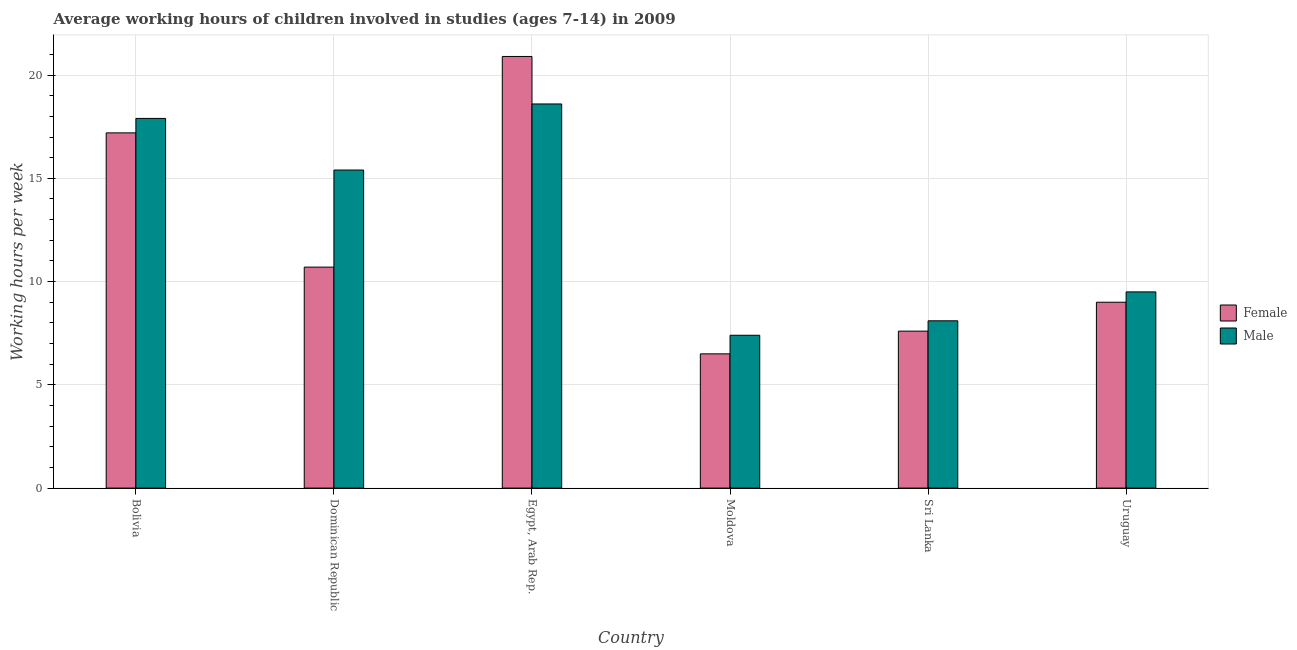Are the number of bars per tick equal to the number of legend labels?
Your response must be concise. Yes. How many bars are there on the 3rd tick from the left?
Make the answer very short. 2. How many bars are there on the 2nd tick from the right?
Provide a short and direct response. 2. What is the label of the 6th group of bars from the left?
Offer a terse response. Uruguay. Across all countries, what is the maximum average working hour of male children?
Your answer should be very brief. 18.6. Across all countries, what is the minimum average working hour of male children?
Your answer should be compact. 7.4. In which country was the average working hour of female children maximum?
Your response must be concise. Egypt, Arab Rep. In which country was the average working hour of male children minimum?
Give a very brief answer. Moldova. What is the total average working hour of male children in the graph?
Your response must be concise. 76.9. What is the difference between the average working hour of female children in Egypt, Arab Rep. and that in Sri Lanka?
Your response must be concise. 13.3. What is the difference between the average working hour of female children in Bolivia and the average working hour of male children in Egypt, Arab Rep.?
Your response must be concise. -1.4. What is the average average working hour of female children per country?
Provide a short and direct response. 11.98. What is the difference between the average working hour of female children and average working hour of male children in Egypt, Arab Rep.?
Keep it short and to the point. 2.3. In how many countries, is the average working hour of female children greater than 18 hours?
Your answer should be very brief. 1. What is the ratio of the average working hour of female children in Sri Lanka to that in Uruguay?
Your response must be concise. 0.84. Is the average working hour of female children in Bolivia less than that in Moldova?
Offer a very short reply. No. What is the difference between the highest and the second highest average working hour of male children?
Offer a terse response. 0.7. What is the difference between the highest and the lowest average working hour of male children?
Offer a terse response. 11.2. Are all the bars in the graph horizontal?
Give a very brief answer. No. How many countries are there in the graph?
Provide a succinct answer. 6. What is the difference between two consecutive major ticks on the Y-axis?
Your response must be concise. 5. Are the values on the major ticks of Y-axis written in scientific E-notation?
Your answer should be compact. No. How many legend labels are there?
Provide a short and direct response. 2. How are the legend labels stacked?
Give a very brief answer. Vertical. What is the title of the graph?
Offer a very short reply. Average working hours of children involved in studies (ages 7-14) in 2009. Does "RDB concessional" appear as one of the legend labels in the graph?
Your answer should be very brief. No. What is the label or title of the X-axis?
Your answer should be compact. Country. What is the label or title of the Y-axis?
Give a very brief answer. Working hours per week. What is the Working hours per week in Female in Bolivia?
Provide a succinct answer. 17.2. What is the Working hours per week of Male in Bolivia?
Give a very brief answer. 17.9. What is the Working hours per week in Male in Dominican Republic?
Offer a very short reply. 15.4. What is the Working hours per week of Female in Egypt, Arab Rep.?
Keep it short and to the point. 20.9. What is the Working hours per week in Male in Egypt, Arab Rep.?
Ensure brevity in your answer.  18.6. What is the Working hours per week of Female in Sri Lanka?
Offer a terse response. 7.6. What is the Working hours per week in Male in Uruguay?
Give a very brief answer. 9.5. Across all countries, what is the maximum Working hours per week in Female?
Provide a short and direct response. 20.9. Across all countries, what is the maximum Working hours per week of Male?
Your answer should be compact. 18.6. Across all countries, what is the minimum Working hours per week in Female?
Provide a short and direct response. 6.5. What is the total Working hours per week of Female in the graph?
Keep it short and to the point. 71.9. What is the total Working hours per week of Male in the graph?
Your answer should be compact. 76.9. What is the difference between the Working hours per week of Female in Bolivia and that in Dominican Republic?
Ensure brevity in your answer.  6.5. What is the difference between the Working hours per week in Male in Bolivia and that in Dominican Republic?
Offer a very short reply. 2.5. What is the difference between the Working hours per week of Female in Bolivia and that in Egypt, Arab Rep.?
Offer a very short reply. -3.7. What is the difference between the Working hours per week in Male in Bolivia and that in Egypt, Arab Rep.?
Give a very brief answer. -0.7. What is the difference between the Working hours per week in Female in Bolivia and that in Uruguay?
Offer a terse response. 8.2. What is the difference between the Working hours per week in Female in Dominican Republic and that in Moldova?
Make the answer very short. 4.2. What is the difference between the Working hours per week of Female in Dominican Republic and that in Sri Lanka?
Keep it short and to the point. 3.1. What is the difference between the Working hours per week in Male in Dominican Republic and that in Uruguay?
Your response must be concise. 5.9. What is the difference between the Working hours per week in Male in Egypt, Arab Rep. and that in Sri Lanka?
Offer a very short reply. 10.5. What is the difference between the Working hours per week of Female in Egypt, Arab Rep. and that in Uruguay?
Your response must be concise. 11.9. What is the difference between the Working hours per week in Male in Egypt, Arab Rep. and that in Uruguay?
Ensure brevity in your answer.  9.1. What is the difference between the Working hours per week in Male in Moldova and that in Sri Lanka?
Provide a short and direct response. -0.7. What is the difference between the Working hours per week in Female in Moldova and that in Uruguay?
Make the answer very short. -2.5. What is the difference between the Working hours per week in Male in Moldova and that in Uruguay?
Make the answer very short. -2.1. What is the difference between the Working hours per week in Male in Sri Lanka and that in Uruguay?
Offer a terse response. -1.4. What is the difference between the Working hours per week in Female in Bolivia and the Working hours per week in Male in Dominican Republic?
Your answer should be compact. 1.8. What is the difference between the Working hours per week of Female in Bolivia and the Working hours per week of Male in Moldova?
Your answer should be compact. 9.8. What is the difference between the Working hours per week of Female in Bolivia and the Working hours per week of Male in Uruguay?
Keep it short and to the point. 7.7. What is the difference between the Working hours per week in Female in Dominican Republic and the Working hours per week in Male in Egypt, Arab Rep.?
Keep it short and to the point. -7.9. What is the difference between the Working hours per week of Female in Dominican Republic and the Working hours per week of Male in Moldova?
Offer a terse response. 3.3. What is the difference between the Working hours per week in Female in Dominican Republic and the Working hours per week in Male in Sri Lanka?
Keep it short and to the point. 2.6. What is the difference between the Working hours per week of Female in Egypt, Arab Rep. and the Working hours per week of Male in Uruguay?
Provide a succinct answer. 11.4. What is the difference between the Working hours per week in Female in Moldova and the Working hours per week in Male in Sri Lanka?
Your answer should be very brief. -1.6. What is the average Working hours per week in Female per country?
Offer a terse response. 11.98. What is the average Working hours per week of Male per country?
Keep it short and to the point. 12.82. What is the difference between the Working hours per week in Female and Working hours per week in Male in Dominican Republic?
Provide a short and direct response. -4.7. What is the difference between the Working hours per week of Female and Working hours per week of Male in Egypt, Arab Rep.?
Ensure brevity in your answer.  2.3. What is the difference between the Working hours per week in Female and Working hours per week in Male in Uruguay?
Ensure brevity in your answer.  -0.5. What is the ratio of the Working hours per week of Female in Bolivia to that in Dominican Republic?
Keep it short and to the point. 1.61. What is the ratio of the Working hours per week in Male in Bolivia to that in Dominican Republic?
Offer a very short reply. 1.16. What is the ratio of the Working hours per week of Female in Bolivia to that in Egypt, Arab Rep.?
Your response must be concise. 0.82. What is the ratio of the Working hours per week of Male in Bolivia to that in Egypt, Arab Rep.?
Provide a short and direct response. 0.96. What is the ratio of the Working hours per week in Female in Bolivia to that in Moldova?
Your answer should be very brief. 2.65. What is the ratio of the Working hours per week of Male in Bolivia to that in Moldova?
Your response must be concise. 2.42. What is the ratio of the Working hours per week of Female in Bolivia to that in Sri Lanka?
Provide a short and direct response. 2.26. What is the ratio of the Working hours per week in Male in Bolivia to that in Sri Lanka?
Your answer should be very brief. 2.21. What is the ratio of the Working hours per week in Female in Bolivia to that in Uruguay?
Keep it short and to the point. 1.91. What is the ratio of the Working hours per week in Male in Bolivia to that in Uruguay?
Offer a very short reply. 1.88. What is the ratio of the Working hours per week in Female in Dominican Republic to that in Egypt, Arab Rep.?
Provide a succinct answer. 0.51. What is the ratio of the Working hours per week in Male in Dominican Republic to that in Egypt, Arab Rep.?
Give a very brief answer. 0.83. What is the ratio of the Working hours per week in Female in Dominican Republic to that in Moldova?
Your answer should be very brief. 1.65. What is the ratio of the Working hours per week of Male in Dominican Republic to that in Moldova?
Your response must be concise. 2.08. What is the ratio of the Working hours per week of Female in Dominican Republic to that in Sri Lanka?
Your response must be concise. 1.41. What is the ratio of the Working hours per week of Male in Dominican Republic to that in Sri Lanka?
Offer a very short reply. 1.9. What is the ratio of the Working hours per week in Female in Dominican Republic to that in Uruguay?
Ensure brevity in your answer.  1.19. What is the ratio of the Working hours per week in Male in Dominican Republic to that in Uruguay?
Make the answer very short. 1.62. What is the ratio of the Working hours per week of Female in Egypt, Arab Rep. to that in Moldova?
Give a very brief answer. 3.22. What is the ratio of the Working hours per week in Male in Egypt, Arab Rep. to that in Moldova?
Offer a terse response. 2.51. What is the ratio of the Working hours per week of Female in Egypt, Arab Rep. to that in Sri Lanka?
Ensure brevity in your answer.  2.75. What is the ratio of the Working hours per week of Male in Egypt, Arab Rep. to that in Sri Lanka?
Offer a very short reply. 2.3. What is the ratio of the Working hours per week in Female in Egypt, Arab Rep. to that in Uruguay?
Ensure brevity in your answer.  2.32. What is the ratio of the Working hours per week in Male in Egypt, Arab Rep. to that in Uruguay?
Provide a succinct answer. 1.96. What is the ratio of the Working hours per week in Female in Moldova to that in Sri Lanka?
Make the answer very short. 0.86. What is the ratio of the Working hours per week of Male in Moldova to that in Sri Lanka?
Your response must be concise. 0.91. What is the ratio of the Working hours per week of Female in Moldova to that in Uruguay?
Provide a short and direct response. 0.72. What is the ratio of the Working hours per week in Male in Moldova to that in Uruguay?
Your answer should be compact. 0.78. What is the ratio of the Working hours per week of Female in Sri Lanka to that in Uruguay?
Ensure brevity in your answer.  0.84. What is the ratio of the Working hours per week of Male in Sri Lanka to that in Uruguay?
Offer a terse response. 0.85. What is the difference between the highest and the second highest Working hours per week in Female?
Offer a very short reply. 3.7. What is the difference between the highest and the second highest Working hours per week in Male?
Your answer should be compact. 0.7. 